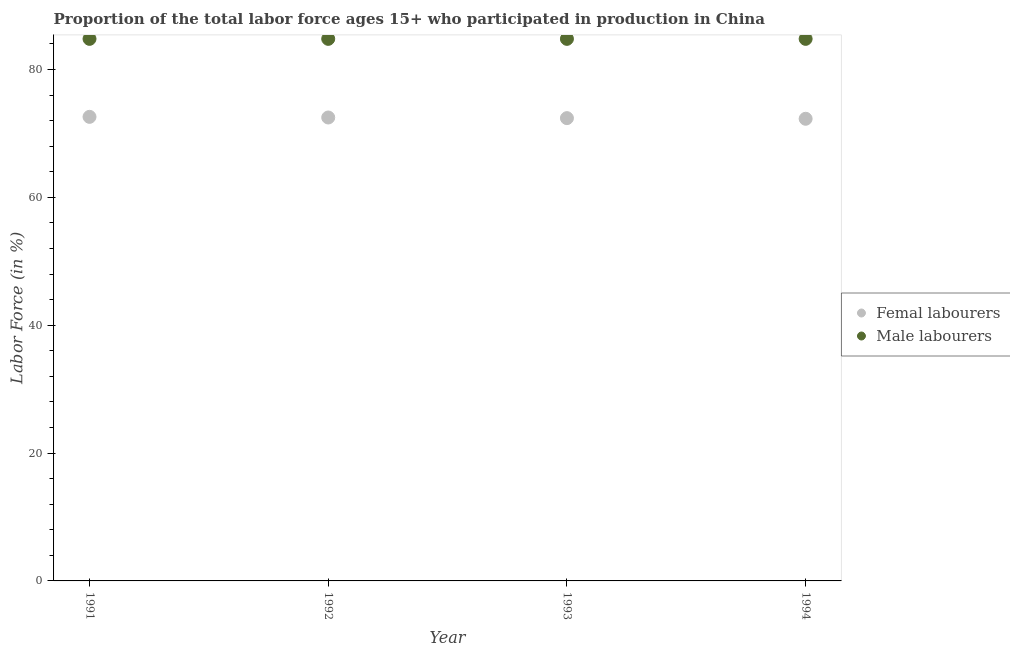Is the number of dotlines equal to the number of legend labels?
Give a very brief answer. Yes. What is the percentage of male labour force in 1994?
Your answer should be very brief. 84.8. Across all years, what is the maximum percentage of female labor force?
Ensure brevity in your answer.  72.6. Across all years, what is the minimum percentage of female labor force?
Offer a terse response. 72.3. In which year was the percentage of male labour force minimum?
Provide a short and direct response. 1991. What is the total percentage of female labor force in the graph?
Offer a terse response. 289.8. What is the difference between the percentage of female labor force in 1993 and the percentage of male labour force in 1991?
Make the answer very short. -12.4. What is the average percentage of female labor force per year?
Ensure brevity in your answer.  72.45. In the year 1993, what is the difference between the percentage of male labour force and percentage of female labor force?
Your answer should be very brief. 12.4. In how many years, is the percentage of male labour force greater than 56 %?
Your response must be concise. 4. What is the ratio of the percentage of male labour force in 1991 to that in 1992?
Your answer should be compact. 1. Is the percentage of female labor force in 1993 less than that in 1994?
Offer a terse response. No. What is the difference between the highest and the lowest percentage of female labor force?
Offer a very short reply. 0.3. In how many years, is the percentage of male labour force greater than the average percentage of male labour force taken over all years?
Offer a terse response. 0. Is the percentage of male labour force strictly greater than the percentage of female labor force over the years?
Keep it short and to the point. Yes. How many dotlines are there?
Offer a very short reply. 2. How many years are there in the graph?
Make the answer very short. 4. What is the difference between two consecutive major ticks on the Y-axis?
Your answer should be compact. 20. Are the values on the major ticks of Y-axis written in scientific E-notation?
Make the answer very short. No. Does the graph contain any zero values?
Provide a succinct answer. No. Does the graph contain grids?
Give a very brief answer. No. How are the legend labels stacked?
Offer a very short reply. Vertical. What is the title of the graph?
Your answer should be very brief. Proportion of the total labor force ages 15+ who participated in production in China. What is the label or title of the Y-axis?
Offer a very short reply. Labor Force (in %). What is the Labor Force (in %) in Femal labourers in 1991?
Provide a short and direct response. 72.6. What is the Labor Force (in %) in Male labourers in 1991?
Offer a very short reply. 84.8. What is the Labor Force (in %) in Femal labourers in 1992?
Your response must be concise. 72.5. What is the Labor Force (in %) in Male labourers in 1992?
Give a very brief answer. 84.8. What is the Labor Force (in %) in Femal labourers in 1993?
Make the answer very short. 72.4. What is the Labor Force (in %) in Male labourers in 1993?
Your answer should be very brief. 84.8. What is the Labor Force (in %) in Femal labourers in 1994?
Offer a terse response. 72.3. What is the Labor Force (in %) in Male labourers in 1994?
Make the answer very short. 84.8. Across all years, what is the maximum Labor Force (in %) in Femal labourers?
Ensure brevity in your answer.  72.6. Across all years, what is the maximum Labor Force (in %) in Male labourers?
Make the answer very short. 84.8. Across all years, what is the minimum Labor Force (in %) of Femal labourers?
Give a very brief answer. 72.3. Across all years, what is the minimum Labor Force (in %) of Male labourers?
Your response must be concise. 84.8. What is the total Labor Force (in %) in Femal labourers in the graph?
Give a very brief answer. 289.8. What is the total Labor Force (in %) of Male labourers in the graph?
Provide a succinct answer. 339.2. What is the difference between the Labor Force (in %) of Femal labourers in 1991 and that in 1992?
Offer a terse response. 0.1. What is the difference between the Labor Force (in %) of Male labourers in 1991 and that in 1993?
Offer a terse response. 0. What is the difference between the Labor Force (in %) of Femal labourers in 1992 and that in 1993?
Make the answer very short. 0.1. What is the difference between the Labor Force (in %) in Femal labourers in 1992 and that in 1994?
Offer a terse response. 0.2. What is the difference between the Labor Force (in %) of Femal labourers in 1993 and that in 1994?
Offer a very short reply. 0.1. What is the difference between the Labor Force (in %) in Male labourers in 1993 and that in 1994?
Your answer should be very brief. 0. What is the difference between the Labor Force (in %) of Femal labourers in 1991 and the Labor Force (in %) of Male labourers in 1993?
Your response must be concise. -12.2. What is the difference between the Labor Force (in %) of Femal labourers in 1991 and the Labor Force (in %) of Male labourers in 1994?
Make the answer very short. -12.2. What is the difference between the Labor Force (in %) of Femal labourers in 1992 and the Labor Force (in %) of Male labourers in 1993?
Ensure brevity in your answer.  -12.3. What is the difference between the Labor Force (in %) of Femal labourers in 1992 and the Labor Force (in %) of Male labourers in 1994?
Provide a succinct answer. -12.3. What is the average Labor Force (in %) of Femal labourers per year?
Your answer should be compact. 72.45. What is the average Labor Force (in %) of Male labourers per year?
Your response must be concise. 84.8. In the year 1992, what is the difference between the Labor Force (in %) in Femal labourers and Labor Force (in %) in Male labourers?
Ensure brevity in your answer.  -12.3. What is the ratio of the Labor Force (in %) in Male labourers in 1991 to that in 1992?
Make the answer very short. 1. What is the ratio of the Labor Force (in %) of Femal labourers in 1991 to that in 1993?
Provide a succinct answer. 1. What is the ratio of the Labor Force (in %) in Femal labourers in 1991 to that in 1994?
Your answer should be compact. 1. What is the ratio of the Labor Force (in %) of Femal labourers in 1992 to that in 1993?
Ensure brevity in your answer.  1. What is the ratio of the Labor Force (in %) of Male labourers in 1992 to that in 1993?
Your response must be concise. 1. What is the ratio of the Labor Force (in %) in Femal labourers in 1992 to that in 1994?
Give a very brief answer. 1. What is the ratio of the Labor Force (in %) of Male labourers in 1992 to that in 1994?
Give a very brief answer. 1. What is the ratio of the Labor Force (in %) of Femal labourers in 1993 to that in 1994?
Offer a very short reply. 1. What is the difference between the highest and the second highest Labor Force (in %) of Femal labourers?
Give a very brief answer. 0.1. What is the difference between the highest and the second highest Labor Force (in %) in Male labourers?
Ensure brevity in your answer.  0. What is the difference between the highest and the lowest Labor Force (in %) in Femal labourers?
Provide a short and direct response. 0.3. What is the difference between the highest and the lowest Labor Force (in %) of Male labourers?
Keep it short and to the point. 0. 